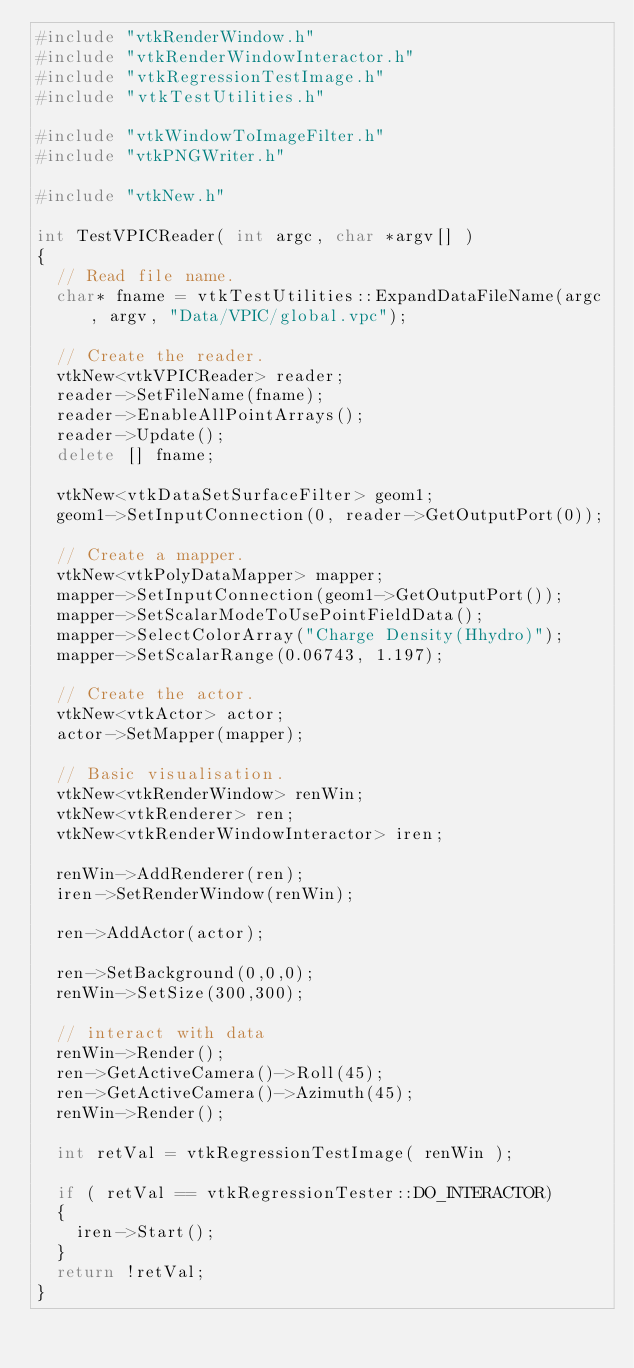Convert code to text. <code><loc_0><loc_0><loc_500><loc_500><_C++_>#include "vtkRenderWindow.h"
#include "vtkRenderWindowInteractor.h"
#include "vtkRegressionTestImage.h"
#include "vtkTestUtilities.h"

#include "vtkWindowToImageFilter.h"
#include "vtkPNGWriter.h"

#include "vtkNew.h"

int TestVPICReader( int argc, char *argv[] )
{
  // Read file name.
  char* fname = vtkTestUtilities::ExpandDataFileName(argc, argv, "Data/VPIC/global.vpc");

  // Create the reader.
  vtkNew<vtkVPICReader> reader;
  reader->SetFileName(fname);
  reader->EnableAllPointArrays();
  reader->Update();
  delete [] fname;

  vtkNew<vtkDataSetSurfaceFilter> geom1;
  geom1->SetInputConnection(0, reader->GetOutputPort(0));

  // Create a mapper.
  vtkNew<vtkPolyDataMapper> mapper;
  mapper->SetInputConnection(geom1->GetOutputPort());
  mapper->SetScalarModeToUsePointFieldData();
  mapper->SelectColorArray("Charge Density(Hhydro)");
  mapper->SetScalarRange(0.06743, 1.197);

  // Create the actor.
  vtkNew<vtkActor> actor;
  actor->SetMapper(mapper);

  // Basic visualisation.
  vtkNew<vtkRenderWindow> renWin;
  vtkNew<vtkRenderer> ren;
  vtkNew<vtkRenderWindowInteractor> iren;

  renWin->AddRenderer(ren);
  iren->SetRenderWindow(renWin);

  ren->AddActor(actor);

  ren->SetBackground(0,0,0);
  renWin->SetSize(300,300);

  // interact with data
  renWin->Render();
  ren->GetActiveCamera()->Roll(45);
  ren->GetActiveCamera()->Azimuth(45);
  renWin->Render();

  int retVal = vtkRegressionTestImage( renWin );

  if ( retVal == vtkRegressionTester::DO_INTERACTOR)
  {
    iren->Start();
  }
  return !retVal;
}
</code> 